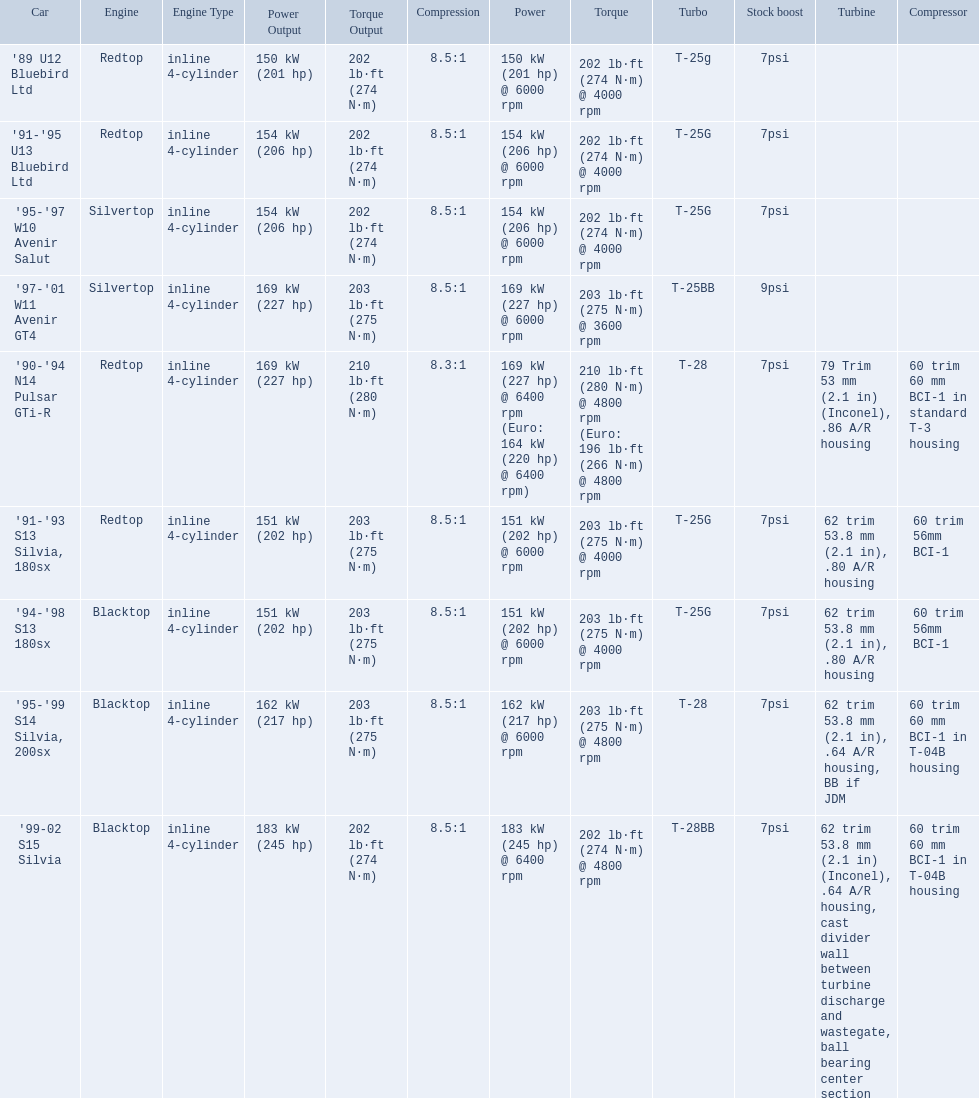What are all of the nissan cars? '89 U12 Bluebird Ltd, '91-'95 U13 Bluebird Ltd, '95-'97 W10 Avenir Salut, '97-'01 W11 Avenir GT4, '90-'94 N14 Pulsar GTi-R, '91-'93 S13 Silvia, 180sx, '94-'98 S13 180sx, '95-'99 S14 Silvia, 200sx, '99-02 S15 Silvia. Of these cars, which one is a '90-'94 n14 pulsar gti-r? '90-'94 N14 Pulsar GTi-R. What is the compression of this car? 8.3:1. 